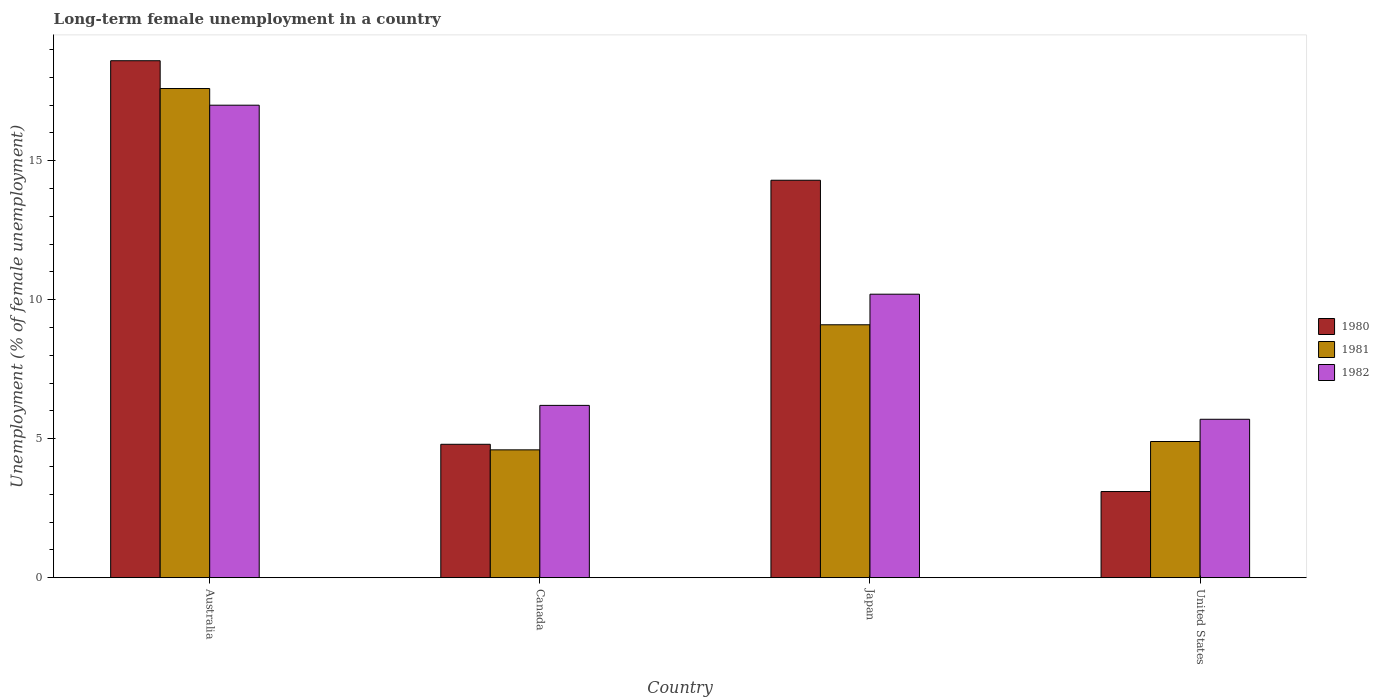How many groups of bars are there?
Offer a very short reply. 4. Are the number of bars on each tick of the X-axis equal?
Give a very brief answer. Yes. How many bars are there on the 3rd tick from the left?
Ensure brevity in your answer.  3. How many bars are there on the 3rd tick from the right?
Keep it short and to the point. 3. In how many cases, is the number of bars for a given country not equal to the number of legend labels?
Give a very brief answer. 0. What is the percentage of long-term unemployed female population in 1980 in Australia?
Provide a short and direct response. 18.6. Across all countries, what is the maximum percentage of long-term unemployed female population in 1981?
Provide a succinct answer. 17.6. Across all countries, what is the minimum percentage of long-term unemployed female population in 1982?
Your answer should be very brief. 5.7. In which country was the percentage of long-term unemployed female population in 1980 maximum?
Keep it short and to the point. Australia. In which country was the percentage of long-term unemployed female population in 1982 minimum?
Offer a terse response. United States. What is the total percentage of long-term unemployed female population in 1981 in the graph?
Give a very brief answer. 36.2. What is the difference between the percentage of long-term unemployed female population in 1982 in Japan and that in United States?
Give a very brief answer. 4.5. What is the difference between the percentage of long-term unemployed female population in 1982 in Australia and the percentage of long-term unemployed female population in 1981 in United States?
Your answer should be compact. 12.1. What is the average percentage of long-term unemployed female population in 1980 per country?
Your answer should be compact. 10.2. What is the difference between the percentage of long-term unemployed female population of/in 1982 and percentage of long-term unemployed female population of/in 1981 in United States?
Give a very brief answer. 0.8. In how many countries, is the percentage of long-term unemployed female population in 1982 greater than 18 %?
Provide a succinct answer. 0. What is the ratio of the percentage of long-term unemployed female population in 1982 in Canada to that in United States?
Your response must be concise. 1.09. Is the percentage of long-term unemployed female population in 1980 in Japan less than that in United States?
Your answer should be compact. No. Is the difference between the percentage of long-term unemployed female population in 1982 in Canada and Japan greater than the difference between the percentage of long-term unemployed female population in 1981 in Canada and Japan?
Offer a terse response. Yes. What is the difference between the highest and the second highest percentage of long-term unemployed female population in 1980?
Give a very brief answer. 13.8. What is the difference between the highest and the lowest percentage of long-term unemployed female population in 1982?
Give a very brief answer. 11.3. Is the sum of the percentage of long-term unemployed female population in 1981 in Australia and United States greater than the maximum percentage of long-term unemployed female population in 1982 across all countries?
Keep it short and to the point. Yes. What does the 1st bar from the right in United States represents?
Ensure brevity in your answer.  1982. How many countries are there in the graph?
Your answer should be very brief. 4. What is the difference between two consecutive major ticks on the Y-axis?
Make the answer very short. 5. Does the graph contain any zero values?
Your answer should be compact. No. Does the graph contain grids?
Ensure brevity in your answer.  No. Where does the legend appear in the graph?
Your response must be concise. Center right. How many legend labels are there?
Make the answer very short. 3. How are the legend labels stacked?
Give a very brief answer. Vertical. What is the title of the graph?
Make the answer very short. Long-term female unemployment in a country. Does "2015" appear as one of the legend labels in the graph?
Your answer should be compact. No. What is the label or title of the Y-axis?
Keep it short and to the point. Unemployment (% of female unemployment). What is the Unemployment (% of female unemployment) in 1980 in Australia?
Keep it short and to the point. 18.6. What is the Unemployment (% of female unemployment) of 1981 in Australia?
Provide a succinct answer. 17.6. What is the Unemployment (% of female unemployment) in 1982 in Australia?
Ensure brevity in your answer.  17. What is the Unemployment (% of female unemployment) of 1980 in Canada?
Your answer should be compact. 4.8. What is the Unemployment (% of female unemployment) in 1981 in Canada?
Your answer should be very brief. 4.6. What is the Unemployment (% of female unemployment) in 1982 in Canada?
Give a very brief answer. 6.2. What is the Unemployment (% of female unemployment) in 1980 in Japan?
Your answer should be compact. 14.3. What is the Unemployment (% of female unemployment) in 1981 in Japan?
Your response must be concise. 9.1. What is the Unemployment (% of female unemployment) of 1982 in Japan?
Provide a succinct answer. 10.2. What is the Unemployment (% of female unemployment) in 1980 in United States?
Offer a very short reply. 3.1. What is the Unemployment (% of female unemployment) in 1981 in United States?
Offer a terse response. 4.9. What is the Unemployment (% of female unemployment) in 1982 in United States?
Your answer should be very brief. 5.7. Across all countries, what is the maximum Unemployment (% of female unemployment) of 1980?
Offer a very short reply. 18.6. Across all countries, what is the maximum Unemployment (% of female unemployment) of 1981?
Offer a terse response. 17.6. Across all countries, what is the maximum Unemployment (% of female unemployment) of 1982?
Offer a terse response. 17. Across all countries, what is the minimum Unemployment (% of female unemployment) in 1980?
Offer a terse response. 3.1. Across all countries, what is the minimum Unemployment (% of female unemployment) of 1981?
Ensure brevity in your answer.  4.6. Across all countries, what is the minimum Unemployment (% of female unemployment) in 1982?
Keep it short and to the point. 5.7. What is the total Unemployment (% of female unemployment) in 1980 in the graph?
Provide a succinct answer. 40.8. What is the total Unemployment (% of female unemployment) in 1981 in the graph?
Provide a succinct answer. 36.2. What is the total Unemployment (% of female unemployment) of 1982 in the graph?
Keep it short and to the point. 39.1. What is the difference between the Unemployment (% of female unemployment) of 1980 in Australia and that in Canada?
Offer a very short reply. 13.8. What is the difference between the Unemployment (% of female unemployment) in 1981 in Australia and that in Canada?
Offer a very short reply. 13. What is the difference between the Unemployment (% of female unemployment) of 1982 in Australia and that in Canada?
Your answer should be compact. 10.8. What is the difference between the Unemployment (% of female unemployment) of 1980 in Australia and that in Japan?
Your answer should be compact. 4.3. What is the difference between the Unemployment (% of female unemployment) in 1981 in Australia and that in Japan?
Ensure brevity in your answer.  8.5. What is the difference between the Unemployment (% of female unemployment) in 1982 in Australia and that in Japan?
Ensure brevity in your answer.  6.8. What is the difference between the Unemployment (% of female unemployment) of 1980 in Australia and that in United States?
Your answer should be very brief. 15.5. What is the difference between the Unemployment (% of female unemployment) in 1982 in Australia and that in United States?
Provide a succinct answer. 11.3. What is the difference between the Unemployment (% of female unemployment) in 1982 in Canada and that in Japan?
Your answer should be very brief. -4. What is the difference between the Unemployment (% of female unemployment) in 1980 in Japan and that in United States?
Provide a short and direct response. 11.2. What is the difference between the Unemployment (% of female unemployment) in 1981 in Australia and the Unemployment (% of female unemployment) in 1982 in Canada?
Your answer should be compact. 11.4. What is the difference between the Unemployment (% of female unemployment) of 1980 in Australia and the Unemployment (% of female unemployment) of 1981 in Japan?
Your answer should be very brief. 9.5. What is the difference between the Unemployment (% of female unemployment) in 1980 in Australia and the Unemployment (% of female unemployment) in 1982 in Japan?
Offer a terse response. 8.4. What is the difference between the Unemployment (% of female unemployment) in 1981 in Australia and the Unemployment (% of female unemployment) in 1982 in Japan?
Your answer should be very brief. 7.4. What is the difference between the Unemployment (% of female unemployment) of 1980 in Australia and the Unemployment (% of female unemployment) of 1981 in United States?
Provide a succinct answer. 13.7. What is the difference between the Unemployment (% of female unemployment) in 1980 in Australia and the Unemployment (% of female unemployment) in 1982 in United States?
Keep it short and to the point. 12.9. What is the difference between the Unemployment (% of female unemployment) in 1981 in Australia and the Unemployment (% of female unemployment) in 1982 in United States?
Give a very brief answer. 11.9. What is the difference between the Unemployment (% of female unemployment) in 1980 in Canada and the Unemployment (% of female unemployment) in 1981 in Japan?
Ensure brevity in your answer.  -4.3. What is the difference between the Unemployment (% of female unemployment) in 1980 in Canada and the Unemployment (% of female unemployment) in 1982 in Japan?
Provide a short and direct response. -5.4. What is the average Unemployment (% of female unemployment) in 1980 per country?
Keep it short and to the point. 10.2. What is the average Unemployment (% of female unemployment) in 1981 per country?
Your answer should be compact. 9.05. What is the average Unemployment (% of female unemployment) in 1982 per country?
Your answer should be very brief. 9.78. What is the difference between the Unemployment (% of female unemployment) of 1981 and Unemployment (% of female unemployment) of 1982 in Australia?
Provide a succinct answer. 0.6. What is the difference between the Unemployment (% of female unemployment) of 1980 and Unemployment (% of female unemployment) of 1982 in Canada?
Keep it short and to the point. -1.4. What is the difference between the Unemployment (% of female unemployment) in 1980 and Unemployment (% of female unemployment) in 1981 in Japan?
Offer a terse response. 5.2. What is the difference between the Unemployment (% of female unemployment) in 1980 and Unemployment (% of female unemployment) in 1982 in Japan?
Offer a very short reply. 4.1. What is the difference between the Unemployment (% of female unemployment) of 1981 and Unemployment (% of female unemployment) of 1982 in Japan?
Keep it short and to the point. -1.1. What is the difference between the Unemployment (% of female unemployment) in 1980 and Unemployment (% of female unemployment) in 1981 in United States?
Keep it short and to the point. -1.8. What is the difference between the Unemployment (% of female unemployment) of 1980 and Unemployment (% of female unemployment) of 1982 in United States?
Your response must be concise. -2.6. What is the difference between the Unemployment (% of female unemployment) in 1981 and Unemployment (% of female unemployment) in 1982 in United States?
Offer a terse response. -0.8. What is the ratio of the Unemployment (% of female unemployment) of 1980 in Australia to that in Canada?
Give a very brief answer. 3.88. What is the ratio of the Unemployment (% of female unemployment) in 1981 in Australia to that in Canada?
Make the answer very short. 3.83. What is the ratio of the Unemployment (% of female unemployment) of 1982 in Australia to that in Canada?
Offer a very short reply. 2.74. What is the ratio of the Unemployment (% of female unemployment) in 1980 in Australia to that in Japan?
Give a very brief answer. 1.3. What is the ratio of the Unemployment (% of female unemployment) in 1981 in Australia to that in Japan?
Your answer should be compact. 1.93. What is the ratio of the Unemployment (% of female unemployment) of 1980 in Australia to that in United States?
Give a very brief answer. 6. What is the ratio of the Unemployment (% of female unemployment) of 1981 in Australia to that in United States?
Provide a succinct answer. 3.59. What is the ratio of the Unemployment (% of female unemployment) of 1982 in Australia to that in United States?
Make the answer very short. 2.98. What is the ratio of the Unemployment (% of female unemployment) in 1980 in Canada to that in Japan?
Give a very brief answer. 0.34. What is the ratio of the Unemployment (% of female unemployment) in 1981 in Canada to that in Japan?
Offer a terse response. 0.51. What is the ratio of the Unemployment (% of female unemployment) of 1982 in Canada to that in Japan?
Provide a short and direct response. 0.61. What is the ratio of the Unemployment (% of female unemployment) of 1980 in Canada to that in United States?
Give a very brief answer. 1.55. What is the ratio of the Unemployment (% of female unemployment) of 1981 in Canada to that in United States?
Keep it short and to the point. 0.94. What is the ratio of the Unemployment (% of female unemployment) in 1982 in Canada to that in United States?
Provide a succinct answer. 1.09. What is the ratio of the Unemployment (% of female unemployment) in 1980 in Japan to that in United States?
Your response must be concise. 4.61. What is the ratio of the Unemployment (% of female unemployment) of 1981 in Japan to that in United States?
Offer a very short reply. 1.86. What is the ratio of the Unemployment (% of female unemployment) of 1982 in Japan to that in United States?
Make the answer very short. 1.79. 